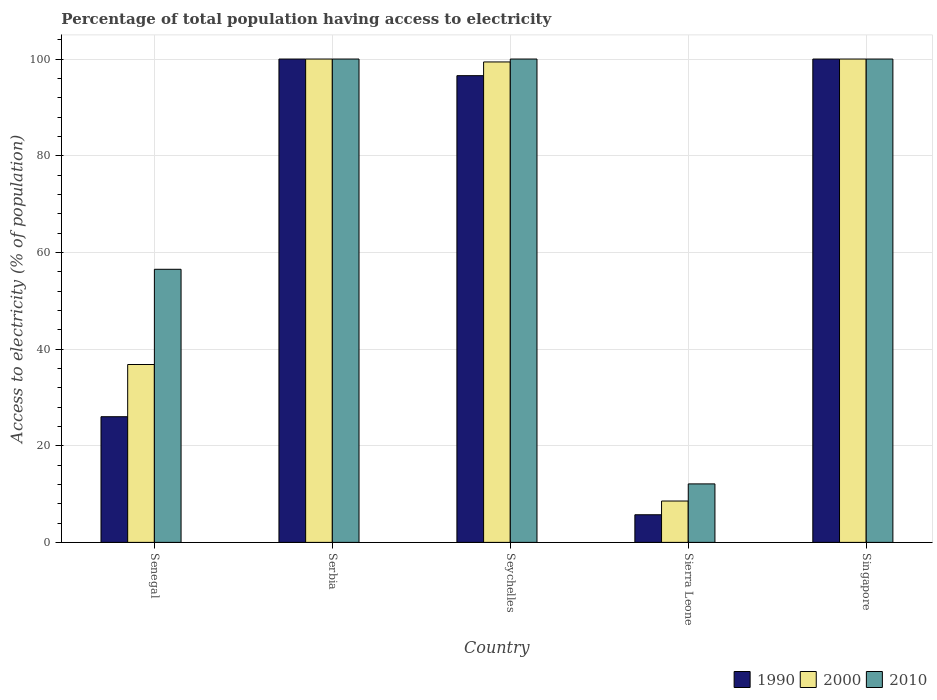Are the number of bars per tick equal to the number of legend labels?
Your response must be concise. Yes. How many bars are there on the 5th tick from the left?
Your answer should be very brief. 3. How many bars are there on the 1st tick from the right?
Make the answer very short. 3. What is the label of the 5th group of bars from the left?
Offer a very short reply. Singapore. In how many cases, is the number of bars for a given country not equal to the number of legend labels?
Make the answer very short. 0. Across all countries, what is the maximum percentage of population that have access to electricity in 2000?
Keep it short and to the point. 100. Across all countries, what is the minimum percentage of population that have access to electricity in 2000?
Your answer should be very brief. 8.56. In which country was the percentage of population that have access to electricity in 2000 maximum?
Your answer should be very brief. Serbia. In which country was the percentage of population that have access to electricity in 2010 minimum?
Make the answer very short. Sierra Leone. What is the total percentage of population that have access to electricity in 1990 in the graph?
Ensure brevity in your answer.  328.28. What is the difference between the percentage of population that have access to electricity in 2000 in Senegal and that in Serbia?
Keep it short and to the point. -63.2. What is the difference between the percentage of population that have access to electricity in 1990 in Sierra Leone and the percentage of population that have access to electricity in 2000 in Serbia?
Your answer should be compact. -94.28. What is the average percentage of population that have access to electricity in 2010 per country?
Offer a terse response. 73.72. What is the difference between the percentage of population that have access to electricity of/in 2010 and percentage of population that have access to electricity of/in 1990 in Singapore?
Offer a terse response. 0. What is the ratio of the percentage of population that have access to electricity in 2010 in Senegal to that in Singapore?
Provide a short and direct response. 0.56. Is the percentage of population that have access to electricity in 2000 in Serbia less than that in Singapore?
Offer a very short reply. No. What is the difference between the highest and the second highest percentage of population that have access to electricity in 1990?
Make the answer very short. -3.44. What is the difference between the highest and the lowest percentage of population that have access to electricity in 2010?
Provide a short and direct response. 87.9. Are all the bars in the graph horizontal?
Offer a terse response. No. How many countries are there in the graph?
Make the answer very short. 5. What is the difference between two consecutive major ticks on the Y-axis?
Provide a succinct answer. 20. Does the graph contain grids?
Provide a succinct answer. Yes. Where does the legend appear in the graph?
Offer a terse response. Bottom right. What is the title of the graph?
Give a very brief answer. Percentage of total population having access to electricity. What is the label or title of the Y-axis?
Offer a very short reply. Access to electricity (% of population). What is the Access to electricity (% of population) in 1990 in Senegal?
Your answer should be compact. 26. What is the Access to electricity (% of population) in 2000 in Senegal?
Keep it short and to the point. 36.8. What is the Access to electricity (% of population) in 2010 in Senegal?
Provide a short and direct response. 56.5. What is the Access to electricity (% of population) in 1990 in Serbia?
Your answer should be very brief. 100. What is the Access to electricity (% of population) of 2000 in Serbia?
Provide a short and direct response. 100. What is the Access to electricity (% of population) in 2010 in Serbia?
Your answer should be compact. 100. What is the Access to electricity (% of population) in 1990 in Seychelles?
Keep it short and to the point. 96.56. What is the Access to electricity (% of population) of 2000 in Seychelles?
Your answer should be compact. 99.4. What is the Access to electricity (% of population) in 1990 in Sierra Leone?
Give a very brief answer. 5.72. What is the Access to electricity (% of population) in 2000 in Sierra Leone?
Your answer should be compact. 8.56. What is the Access to electricity (% of population) of 1990 in Singapore?
Keep it short and to the point. 100. What is the Access to electricity (% of population) in 2000 in Singapore?
Your answer should be very brief. 100. What is the Access to electricity (% of population) in 2010 in Singapore?
Provide a short and direct response. 100. Across all countries, what is the maximum Access to electricity (% of population) of 1990?
Keep it short and to the point. 100. Across all countries, what is the minimum Access to electricity (% of population) of 1990?
Ensure brevity in your answer.  5.72. Across all countries, what is the minimum Access to electricity (% of population) of 2000?
Your answer should be compact. 8.56. Across all countries, what is the minimum Access to electricity (% of population) in 2010?
Provide a succinct answer. 12.1. What is the total Access to electricity (% of population) in 1990 in the graph?
Make the answer very short. 328.28. What is the total Access to electricity (% of population) in 2000 in the graph?
Your answer should be compact. 344.76. What is the total Access to electricity (% of population) in 2010 in the graph?
Offer a terse response. 368.6. What is the difference between the Access to electricity (% of population) in 1990 in Senegal and that in Serbia?
Offer a very short reply. -74. What is the difference between the Access to electricity (% of population) in 2000 in Senegal and that in Serbia?
Offer a terse response. -63.2. What is the difference between the Access to electricity (% of population) in 2010 in Senegal and that in Serbia?
Make the answer very short. -43.5. What is the difference between the Access to electricity (% of population) in 1990 in Senegal and that in Seychelles?
Keep it short and to the point. -70.56. What is the difference between the Access to electricity (% of population) of 2000 in Senegal and that in Seychelles?
Your answer should be compact. -62.6. What is the difference between the Access to electricity (% of population) in 2010 in Senegal and that in Seychelles?
Give a very brief answer. -43.5. What is the difference between the Access to electricity (% of population) of 1990 in Senegal and that in Sierra Leone?
Give a very brief answer. 20.28. What is the difference between the Access to electricity (% of population) of 2000 in Senegal and that in Sierra Leone?
Ensure brevity in your answer.  28.24. What is the difference between the Access to electricity (% of population) of 2010 in Senegal and that in Sierra Leone?
Ensure brevity in your answer.  44.4. What is the difference between the Access to electricity (% of population) of 1990 in Senegal and that in Singapore?
Make the answer very short. -74. What is the difference between the Access to electricity (% of population) of 2000 in Senegal and that in Singapore?
Ensure brevity in your answer.  -63.2. What is the difference between the Access to electricity (% of population) of 2010 in Senegal and that in Singapore?
Ensure brevity in your answer.  -43.5. What is the difference between the Access to electricity (% of population) in 1990 in Serbia and that in Seychelles?
Your answer should be very brief. 3.44. What is the difference between the Access to electricity (% of population) of 2000 in Serbia and that in Seychelles?
Your answer should be very brief. 0.6. What is the difference between the Access to electricity (% of population) in 2010 in Serbia and that in Seychelles?
Your answer should be compact. 0. What is the difference between the Access to electricity (% of population) of 1990 in Serbia and that in Sierra Leone?
Your response must be concise. 94.28. What is the difference between the Access to electricity (% of population) of 2000 in Serbia and that in Sierra Leone?
Keep it short and to the point. 91.44. What is the difference between the Access to electricity (% of population) in 2010 in Serbia and that in Sierra Leone?
Keep it short and to the point. 87.9. What is the difference between the Access to electricity (% of population) of 1990 in Serbia and that in Singapore?
Ensure brevity in your answer.  0. What is the difference between the Access to electricity (% of population) in 2000 in Serbia and that in Singapore?
Keep it short and to the point. 0. What is the difference between the Access to electricity (% of population) in 1990 in Seychelles and that in Sierra Leone?
Your answer should be compact. 90.84. What is the difference between the Access to electricity (% of population) of 2000 in Seychelles and that in Sierra Leone?
Give a very brief answer. 90.84. What is the difference between the Access to electricity (% of population) in 2010 in Seychelles and that in Sierra Leone?
Ensure brevity in your answer.  87.9. What is the difference between the Access to electricity (% of population) of 1990 in Seychelles and that in Singapore?
Provide a succinct answer. -3.44. What is the difference between the Access to electricity (% of population) of 2000 in Seychelles and that in Singapore?
Offer a terse response. -0.6. What is the difference between the Access to electricity (% of population) in 2010 in Seychelles and that in Singapore?
Give a very brief answer. 0. What is the difference between the Access to electricity (% of population) of 1990 in Sierra Leone and that in Singapore?
Give a very brief answer. -94.28. What is the difference between the Access to electricity (% of population) in 2000 in Sierra Leone and that in Singapore?
Ensure brevity in your answer.  -91.44. What is the difference between the Access to electricity (% of population) of 2010 in Sierra Leone and that in Singapore?
Provide a short and direct response. -87.9. What is the difference between the Access to electricity (% of population) in 1990 in Senegal and the Access to electricity (% of population) in 2000 in Serbia?
Make the answer very short. -74. What is the difference between the Access to electricity (% of population) in 1990 in Senegal and the Access to electricity (% of population) in 2010 in Serbia?
Your answer should be very brief. -74. What is the difference between the Access to electricity (% of population) in 2000 in Senegal and the Access to electricity (% of population) in 2010 in Serbia?
Ensure brevity in your answer.  -63.2. What is the difference between the Access to electricity (% of population) in 1990 in Senegal and the Access to electricity (% of population) in 2000 in Seychelles?
Keep it short and to the point. -73.4. What is the difference between the Access to electricity (% of population) in 1990 in Senegal and the Access to electricity (% of population) in 2010 in Seychelles?
Your answer should be very brief. -74. What is the difference between the Access to electricity (% of population) in 2000 in Senegal and the Access to electricity (% of population) in 2010 in Seychelles?
Your response must be concise. -63.2. What is the difference between the Access to electricity (% of population) of 1990 in Senegal and the Access to electricity (% of population) of 2000 in Sierra Leone?
Your answer should be compact. 17.44. What is the difference between the Access to electricity (% of population) of 2000 in Senegal and the Access to electricity (% of population) of 2010 in Sierra Leone?
Keep it short and to the point. 24.7. What is the difference between the Access to electricity (% of population) in 1990 in Senegal and the Access to electricity (% of population) in 2000 in Singapore?
Provide a short and direct response. -74. What is the difference between the Access to electricity (% of population) in 1990 in Senegal and the Access to electricity (% of population) in 2010 in Singapore?
Provide a succinct answer. -74. What is the difference between the Access to electricity (% of population) of 2000 in Senegal and the Access to electricity (% of population) of 2010 in Singapore?
Provide a short and direct response. -63.2. What is the difference between the Access to electricity (% of population) in 2000 in Serbia and the Access to electricity (% of population) in 2010 in Seychelles?
Your answer should be compact. 0. What is the difference between the Access to electricity (% of population) of 1990 in Serbia and the Access to electricity (% of population) of 2000 in Sierra Leone?
Your answer should be compact. 91.44. What is the difference between the Access to electricity (% of population) of 1990 in Serbia and the Access to electricity (% of population) of 2010 in Sierra Leone?
Make the answer very short. 87.9. What is the difference between the Access to electricity (% of population) of 2000 in Serbia and the Access to electricity (% of population) of 2010 in Sierra Leone?
Ensure brevity in your answer.  87.9. What is the difference between the Access to electricity (% of population) in 1990 in Serbia and the Access to electricity (% of population) in 2000 in Singapore?
Provide a short and direct response. 0. What is the difference between the Access to electricity (% of population) of 1990 in Seychelles and the Access to electricity (% of population) of 2000 in Sierra Leone?
Your answer should be very brief. 88. What is the difference between the Access to electricity (% of population) of 1990 in Seychelles and the Access to electricity (% of population) of 2010 in Sierra Leone?
Make the answer very short. 84.46. What is the difference between the Access to electricity (% of population) of 2000 in Seychelles and the Access to electricity (% of population) of 2010 in Sierra Leone?
Offer a very short reply. 87.3. What is the difference between the Access to electricity (% of population) in 1990 in Seychelles and the Access to electricity (% of population) in 2000 in Singapore?
Your answer should be very brief. -3.44. What is the difference between the Access to electricity (% of population) in 1990 in Seychelles and the Access to electricity (% of population) in 2010 in Singapore?
Your answer should be compact. -3.44. What is the difference between the Access to electricity (% of population) of 2000 in Seychelles and the Access to electricity (% of population) of 2010 in Singapore?
Offer a very short reply. -0.6. What is the difference between the Access to electricity (% of population) of 1990 in Sierra Leone and the Access to electricity (% of population) of 2000 in Singapore?
Provide a succinct answer. -94.28. What is the difference between the Access to electricity (% of population) in 1990 in Sierra Leone and the Access to electricity (% of population) in 2010 in Singapore?
Your answer should be very brief. -94.28. What is the difference between the Access to electricity (% of population) of 2000 in Sierra Leone and the Access to electricity (% of population) of 2010 in Singapore?
Your answer should be very brief. -91.44. What is the average Access to electricity (% of population) in 1990 per country?
Provide a short and direct response. 65.66. What is the average Access to electricity (% of population) in 2000 per country?
Your answer should be very brief. 68.95. What is the average Access to electricity (% of population) of 2010 per country?
Give a very brief answer. 73.72. What is the difference between the Access to electricity (% of population) of 1990 and Access to electricity (% of population) of 2010 in Senegal?
Make the answer very short. -30.5. What is the difference between the Access to electricity (% of population) of 2000 and Access to electricity (% of population) of 2010 in Senegal?
Offer a very short reply. -19.7. What is the difference between the Access to electricity (% of population) of 1990 and Access to electricity (% of population) of 2000 in Seychelles?
Your response must be concise. -2.84. What is the difference between the Access to electricity (% of population) in 1990 and Access to electricity (% of population) in 2010 in Seychelles?
Offer a very short reply. -3.44. What is the difference between the Access to electricity (% of population) of 1990 and Access to electricity (% of population) of 2000 in Sierra Leone?
Make the answer very short. -2.84. What is the difference between the Access to electricity (% of population) in 1990 and Access to electricity (% of population) in 2010 in Sierra Leone?
Make the answer very short. -6.38. What is the difference between the Access to electricity (% of population) in 2000 and Access to electricity (% of population) in 2010 in Sierra Leone?
Offer a terse response. -3.54. What is the difference between the Access to electricity (% of population) in 1990 and Access to electricity (% of population) in 2000 in Singapore?
Ensure brevity in your answer.  0. What is the difference between the Access to electricity (% of population) in 1990 and Access to electricity (% of population) in 2010 in Singapore?
Provide a short and direct response. 0. What is the ratio of the Access to electricity (% of population) of 1990 in Senegal to that in Serbia?
Offer a very short reply. 0.26. What is the ratio of the Access to electricity (% of population) of 2000 in Senegal to that in Serbia?
Your answer should be compact. 0.37. What is the ratio of the Access to electricity (% of population) of 2010 in Senegal to that in Serbia?
Offer a very short reply. 0.56. What is the ratio of the Access to electricity (% of population) in 1990 in Senegal to that in Seychelles?
Your response must be concise. 0.27. What is the ratio of the Access to electricity (% of population) of 2000 in Senegal to that in Seychelles?
Ensure brevity in your answer.  0.37. What is the ratio of the Access to electricity (% of population) of 2010 in Senegal to that in Seychelles?
Ensure brevity in your answer.  0.56. What is the ratio of the Access to electricity (% of population) in 1990 in Senegal to that in Sierra Leone?
Keep it short and to the point. 4.55. What is the ratio of the Access to electricity (% of population) of 2000 in Senegal to that in Sierra Leone?
Give a very brief answer. 4.3. What is the ratio of the Access to electricity (% of population) of 2010 in Senegal to that in Sierra Leone?
Your answer should be very brief. 4.67. What is the ratio of the Access to electricity (% of population) in 1990 in Senegal to that in Singapore?
Provide a short and direct response. 0.26. What is the ratio of the Access to electricity (% of population) in 2000 in Senegal to that in Singapore?
Your answer should be very brief. 0.37. What is the ratio of the Access to electricity (% of population) in 2010 in Senegal to that in Singapore?
Provide a short and direct response. 0.56. What is the ratio of the Access to electricity (% of population) of 1990 in Serbia to that in Seychelles?
Keep it short and to the point. 1.04. What is the ratio of the Access to electricity (% of population) of 1990 in Serbia to that in Sierra Leone?
Provide a short and direct response. 17.5. What is the ratio of the Access to electricity (% of population) of 2000 in Serbia to that in Sierra Leone?
Give a very brief answer. 11.69. What is the ratio of the Access to electricity (% of population) of 2010 in Serbia to that in Sierra Leone?
Give a very brief answer. 8.26. What is the ratio of the Access to electricity (% of population) of 1990 in Seychelles to that in Sierra Leone?
Make the answer very short. 16.89. What is the ratio of the Access to electricity (% of population) in 2000 in Seychelles to that in Sierra Leone?
Give a very brief answer. 11.62. What is the ratio of the Access to electricity (% of population) of 2010 in Seychelles to that in Sierra Leone?
Offer a very short reply. 8.26. What is the ratio of the Access to electricity (% of population) of 1990 in Seychelles to that in Singapore?
Make the answer very short. 0.97. What is the ratio of the Access to electricity (% of population) in 2010 in Seychelles to that in Singapore?
Your answer should be very brief. 1. What is the ratio of the Access to electricity (% of population) in 1990 in Sierra Leone to that in Singapore?
Keep it short and to the point. 0.06. What is the ratio of the Access to electricity (% of population) in 2000 in Sierra Leone to that in Singapore?
Your answer should be very brief. 0.09. What is the ratio of the Access to electricity (% of population) of 2010 in Sierra Leone to that in Singapore?
Offer a very short reply. 0.12. What is the difference between the highest and the second highest Access to electricity (% of population) of 1990?
Give a very brief answer. 0. What is the difference between the highest and the second highest Access to electricity (% of population) of 2000?
Your response must be concise. 0. What is the difference between the highest and the second highest Access to electricity (% of population) in 2010?
Your response must be concise. 0. What is the difference between the highest and the lowest Access to electricity (% of population) of 1990?
Give a very brief answer. 94.28. What is the difference between the highest and the lowest Access to electricity (% of population) in 2000?
Ensure brevity in your answer.  91.44. What is the difference between the highest and the lowest Access to electricity (% of population) in 2010?
Give a very brief answer. 87.9. 